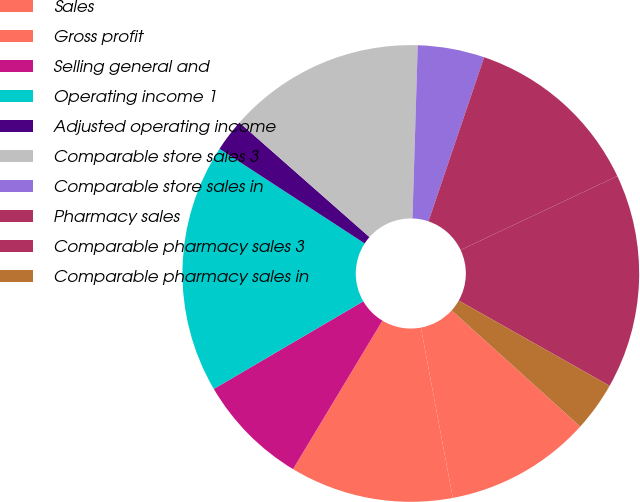Convert chart. <chart><loc_0><loc_0><loc_500><loc_500><pie_chart><fcel>Sales<fcel>Gross profit<fcel>Selling general and<fcel>Operating income 1<fcel>Adjusted operating income<fcel>Comparable store sales 3<fcel>Comparable store sales in<fcel>Pharmacy sales<fcel>Comparable pharmacy sales 3<fcel>Comparable pharmacy sales in<nl><fcel>10.36%<fcel>11.57%<fcel>7.94%<fcel>17.63%<fcel>2.3%<fcel>13.99%<fcel>4.72%<fcel>12.78%<fcel>15.2%<fcel>3.51%<nl></chart> 